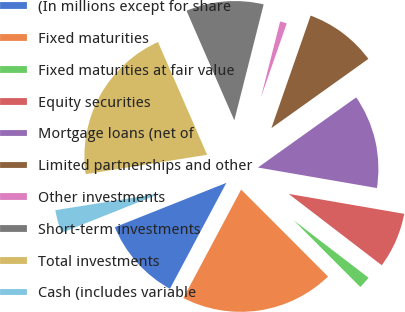<chart> <loc_0><loc_0><loc_500><loc_500><pie_chart><fcel>(In millions except for share<fcel>Fixed maturities<fcel>Fixed maturities at fair value<fcel>Equity securities<fcel>Mortgage loans (net of<fcel>Limited partnerships and other<fcel>Other investments<fcel>Short-term investments<fcel>Total investments<fcel>Cash (includes variable<nl><fcel>11.19%<fcel>20.28%<fcel>2.1%<fcel>7.69%<fcel>12.59%<fcel>9.79%<fcel>1.4%<fcel>10.49%<fcel>20.98%<fcel>3.5%<nl></chart> 